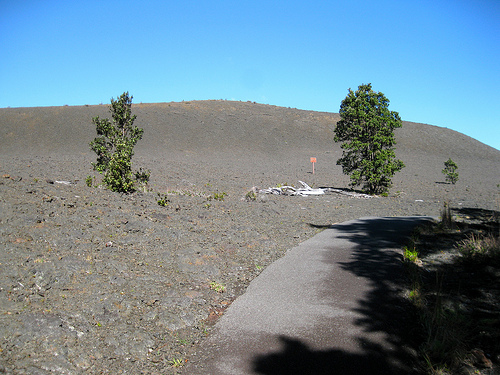<image>
Is the sign on the ground? Yes. Looking at the image, I can see the sign is positioned on top of the ground, with the ground providing support. Is there a bones next to the tree? Yes. The bones is positioned adjacent to the tree, located nearby in the same general area. 